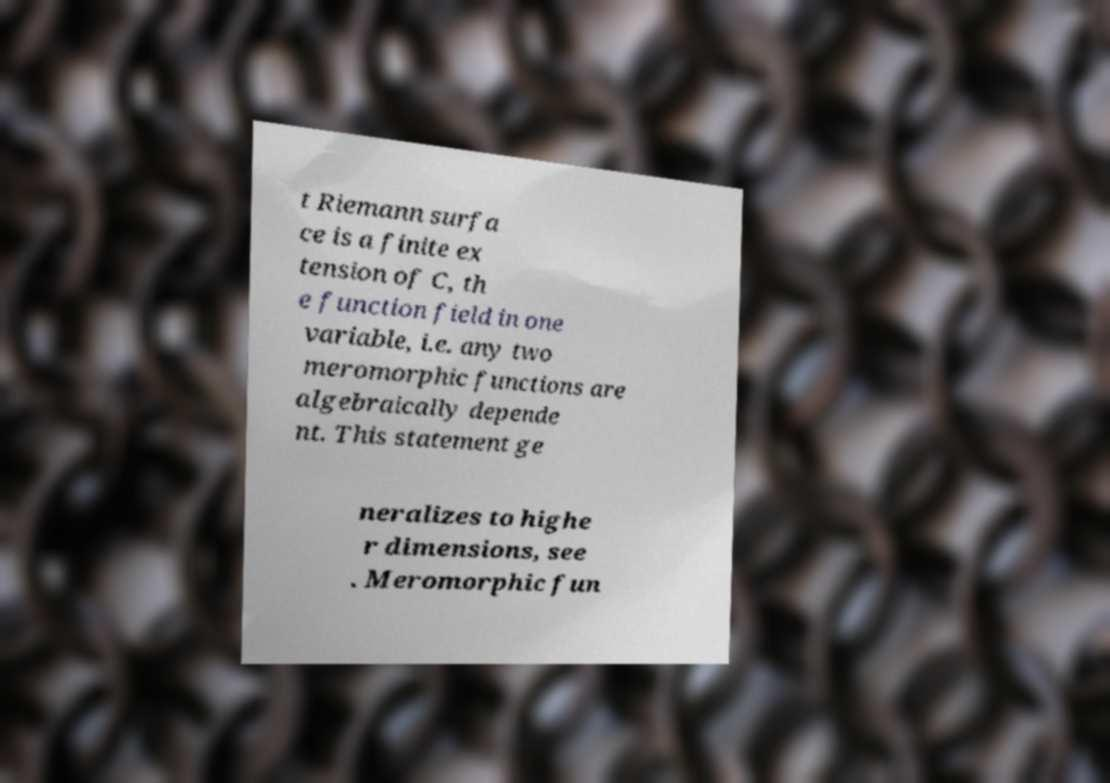Can you read and provide the text displayed in the image?This photo seems to have some interesting text. Can you extract and type it out for me? t Riemann surfa ce is a finite ex tension of C, th e function field in one variable, i.e. any two meromorphic functions are algebraically depende nt. This statement ge neralizes to highe r dimensions, see . Meromorphic fun 